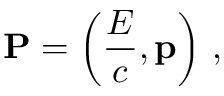Convert formula to latex. <formula><loc_0><loc_0><loc_500><loc_500>P = \left ( { \frac { E } { c } } , p \right ) \, ,</formula> 